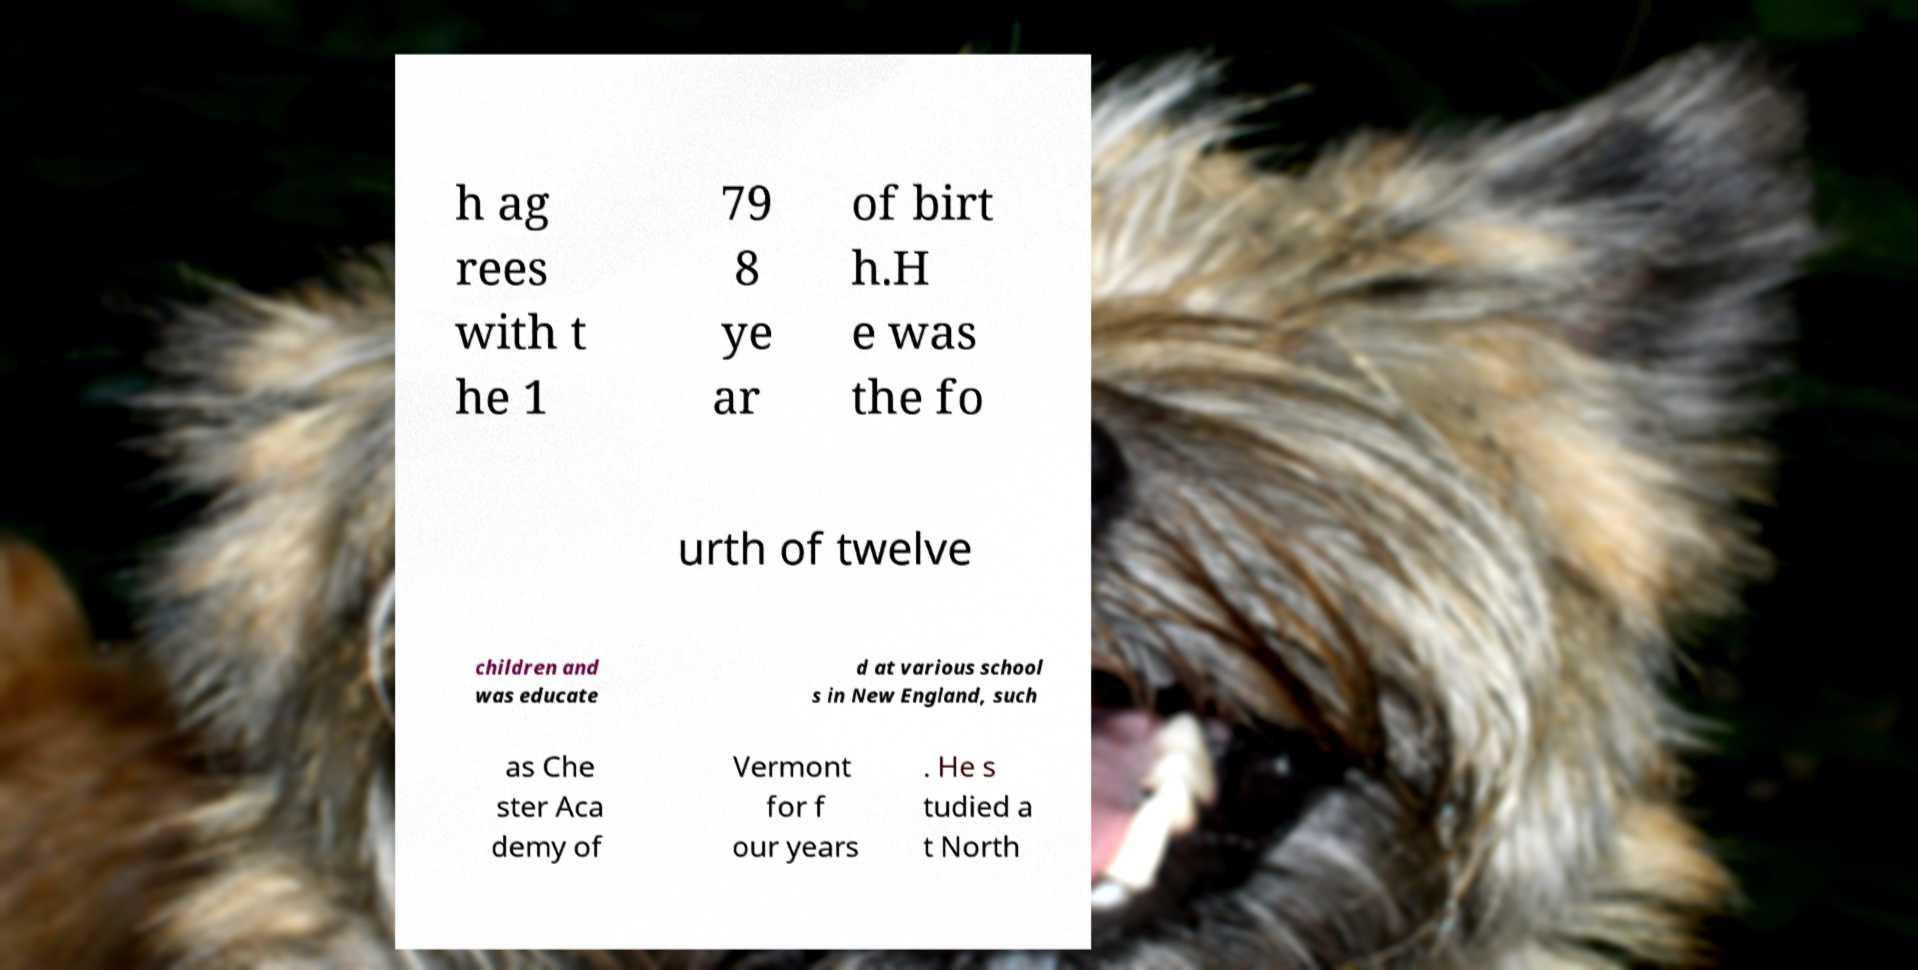Please read and relay the text visible in this image. What does it say? h ag rees with t he 1 79 8 ye ar of birt h.H e was the fo urth of twelve children and was educate d at various school s in New England, such as Che ster Aca demy of Vermont for f our years . He s tudied a t North 